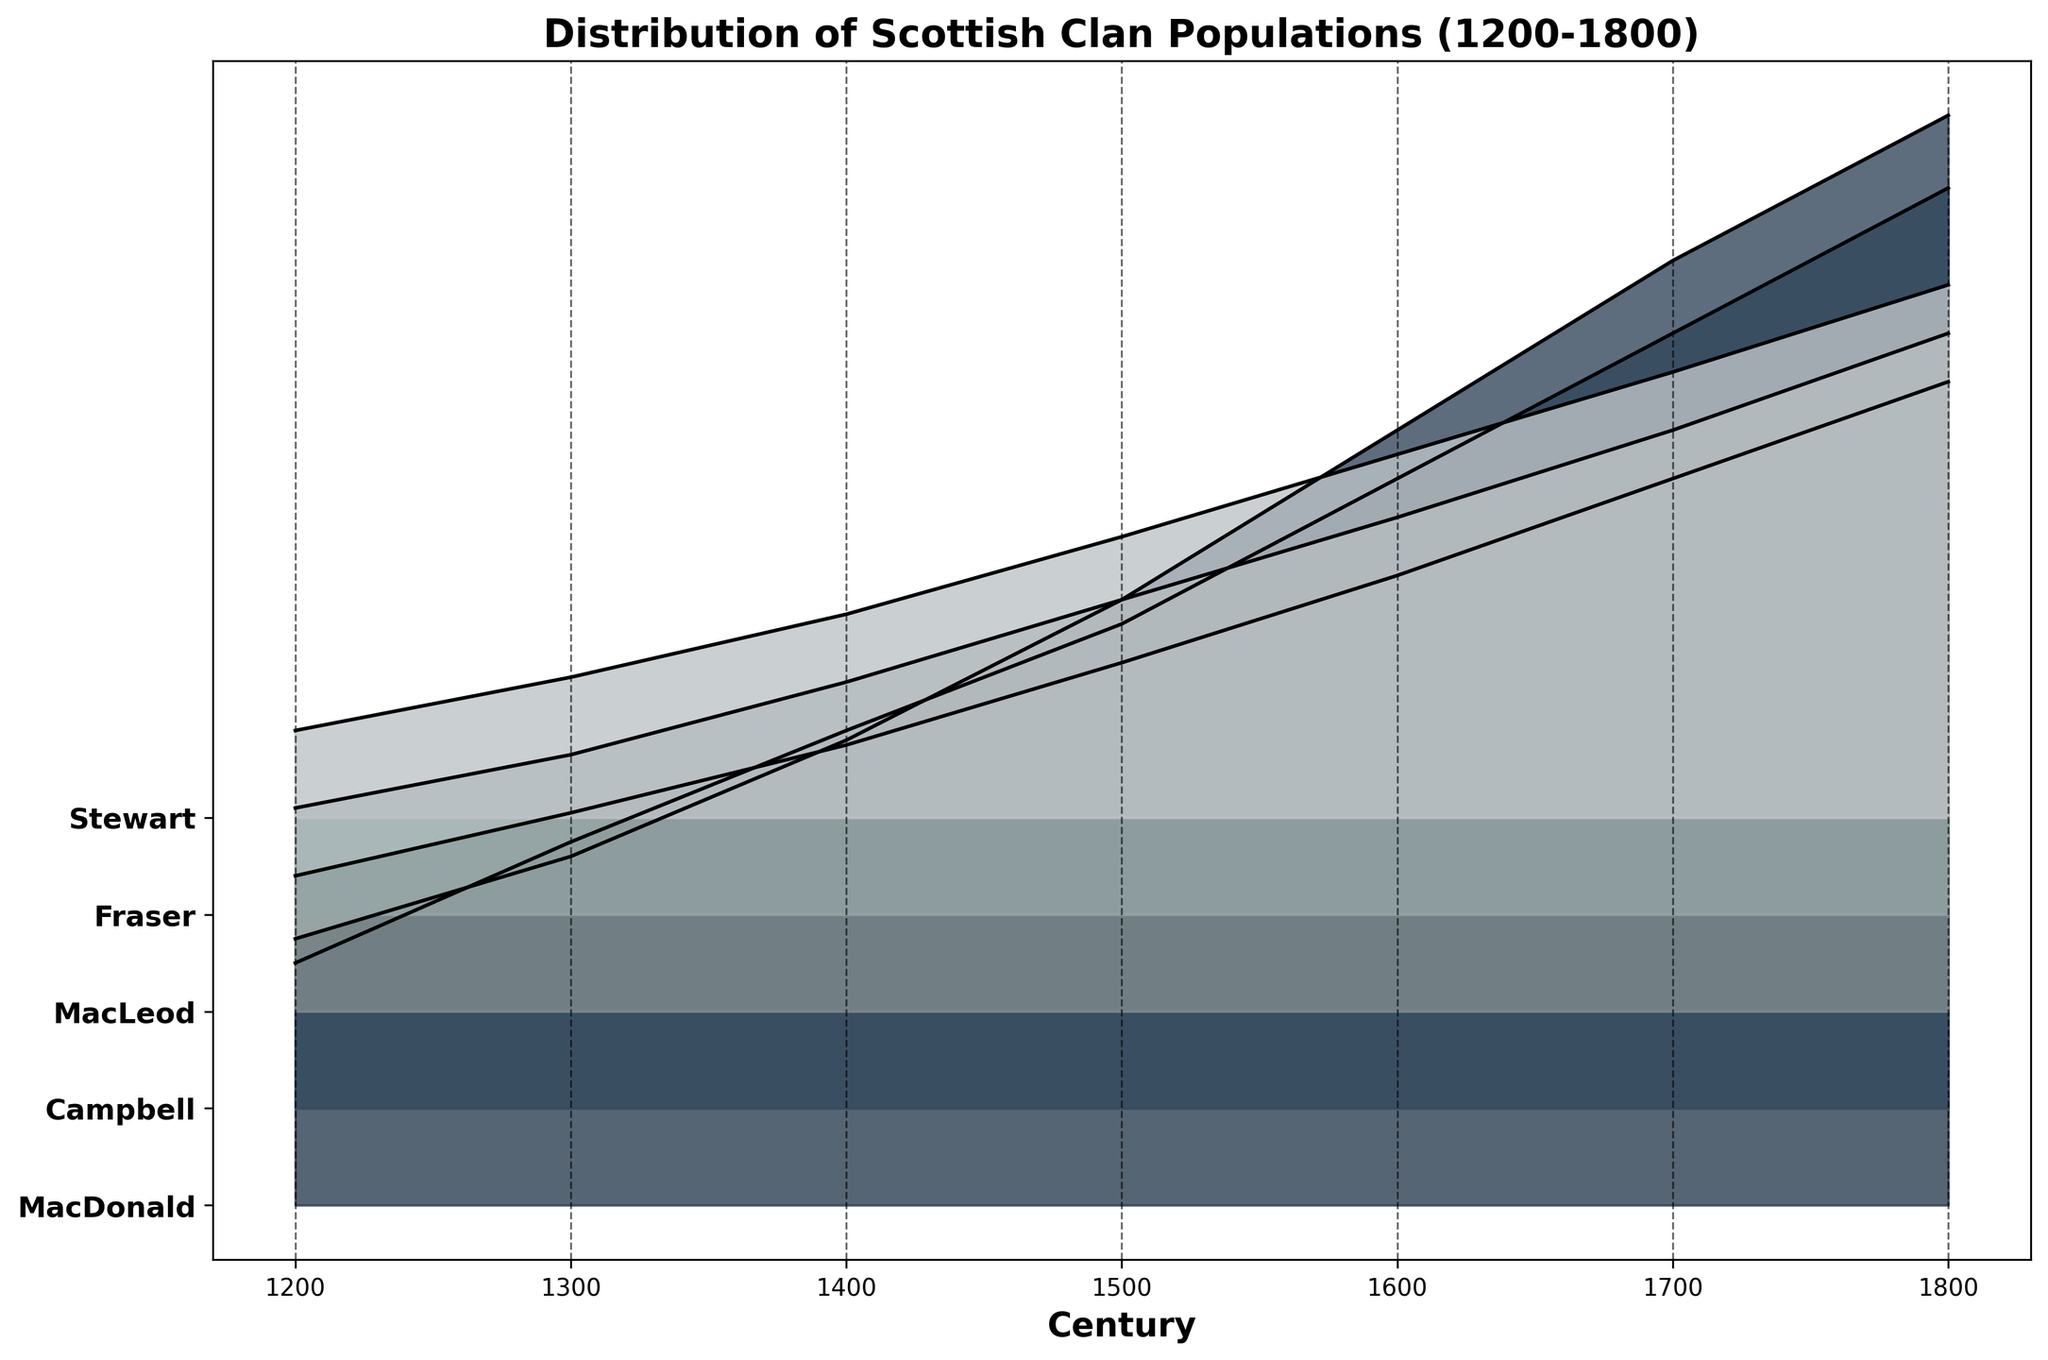What is the title of the plot? The title typically appears at the top of the plot. In this case, it states, "Distribution of Scottish Clan Populations (1200-1800)."
Answer: Distribution of Scottish Clan Populations (1200-1800) Which clan had the highest population in the year 1800? To determine this, look at the 1800 mark on the x-axis and compare the heights of the ridgelines for each clan. The MacDonald clan has the tallest peak.
Answer: MacDonald How did the population of the Campbell clan change from the year 1500 to the year 1800? Compare the height of the Campbell ridgeline in the 1500 and 1800 sections. In 1500, the height of Campbell's ridgeline corresponds to 10,500, while in 1800 it corresponds to 20,500. The population increased by 10,000.
Answer: Increased by 10,000 Which century showed the largest overall increase in population across all clans? To determine the century with the largest overall increase, observe the ridgelines' progression from century to century. The biggest population jump appears between the 1500s and 1600s across all clans.
Answer: 1600s How does the population of the Stewart clan in 1200 compare to its population in 1700? Compare the height of the Stewart ridgeline in the 1200 and 1700 sections. In 1200, the height corresponds to 1,800, and in 1700, it corresponds to 9,200. The population increased by 7,400.
Answer: Increased by 7,400 What is the range of the MacLeod clan's population from 1200 to 1800? The range is the difference between the maximum and minimum populations. MacLeod’s population ranges from 2,800 in 1200 to 13,000 in 1800, so the range is 13,000 - 2,800 = 10,200.
Answer: 10,200 Which clan experienced the smallest population growth between 1300 and 1400? Compare the ridgeline heights in 1300 and 1400 for each clan. The Stewart clan shows the smallest increase: from 2,900 in 1300 to 4,200 in 1400, resulting in an increase of only 1,300.
Answer: Stewart How does the population distribution in the 1600s compare to that in the 1200s? Observe the ridgelines for both centuries. The populations in the 1600s are significantly higher across all clans compared to the populations in the 1200s, indicating overall growth.
Answer: Populations in the 1600s are higher across all clans Between the MacDonald and Fraser clans, which had a greater population in 1500, and by how much? Compare the heights of the ridgelines of MacDonald and Fraser in 1500. MacDonald has a population of 12,000, and Fraser has 6,500. The MacDonald clan has 5,500 more people than the Fraser clan.
Answer: MacDonald by 5,500 